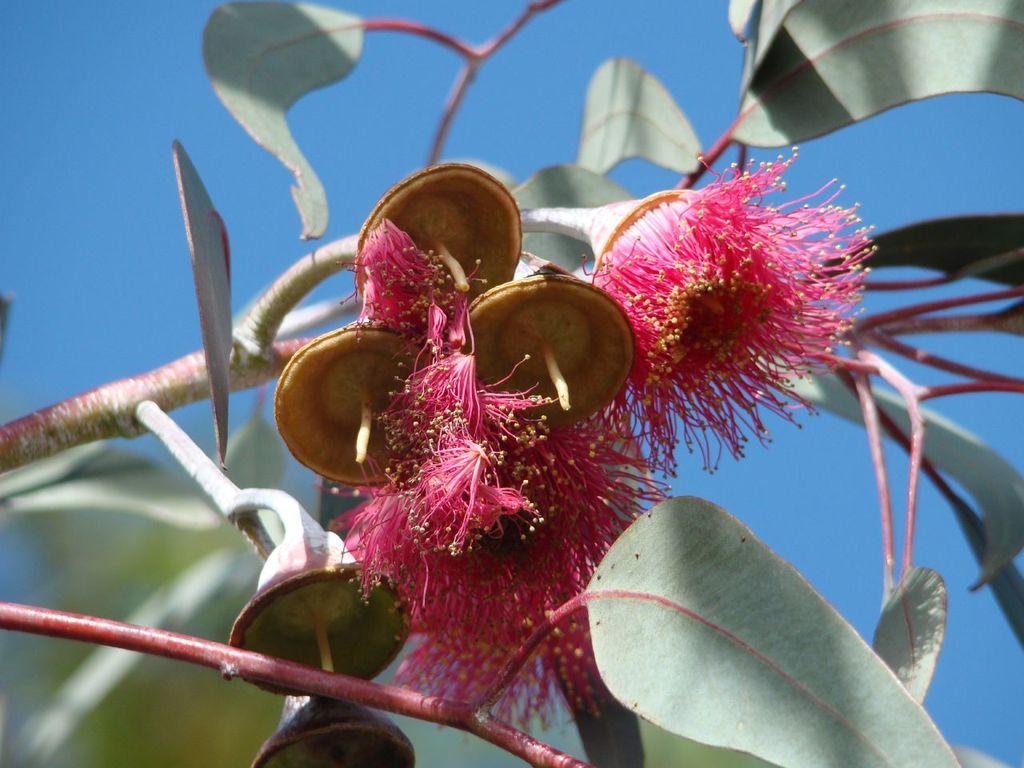How would you summarize this image in a sentence or two? Here we can see flowers, stem and leaves. Background there is a sky. Sky is in blue color. 